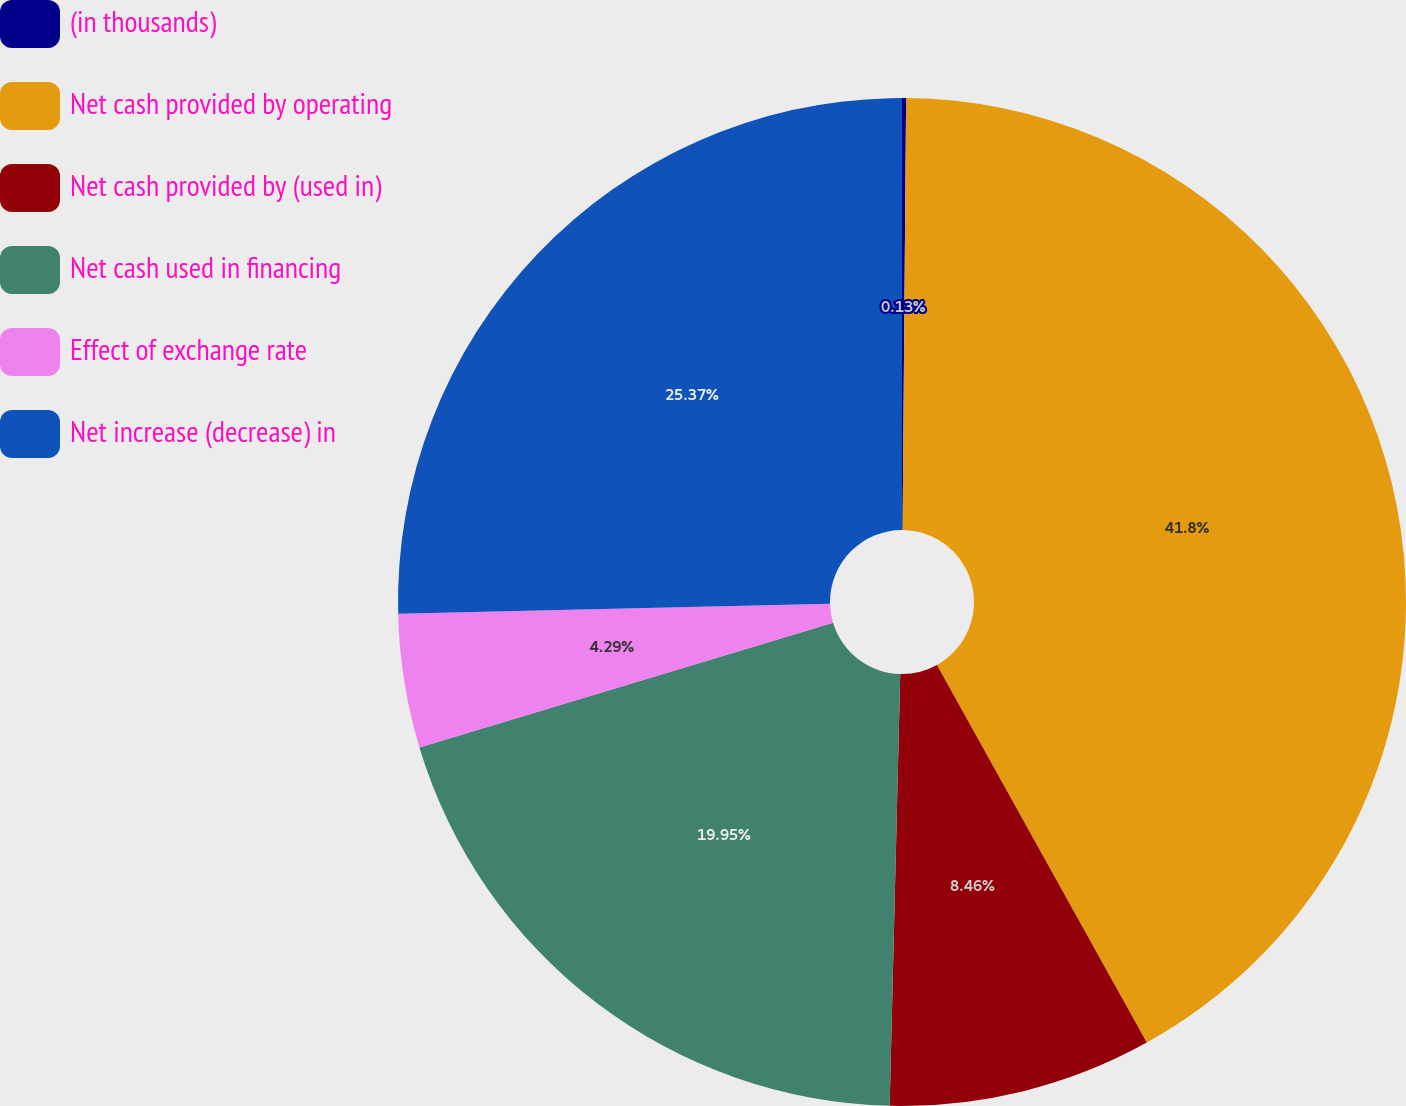Convert chart to OTSL. <chart><loc_0><loc_0><loc_500><loc_500><pie_chart><fcel>(in thousands)<fcel>Net cash provided by operating<fcel>Net cash provided by (used in)<fcel>Net cash used in financing<fcel>Effect of exchange rate<fcel>Net increase (decrease) in<nl><fcel>0.13%<fcel>41.8%<fcel>8.46%<fcel>19.95%<fcel>4.29%<fcel>25.37%<nl></chart> 